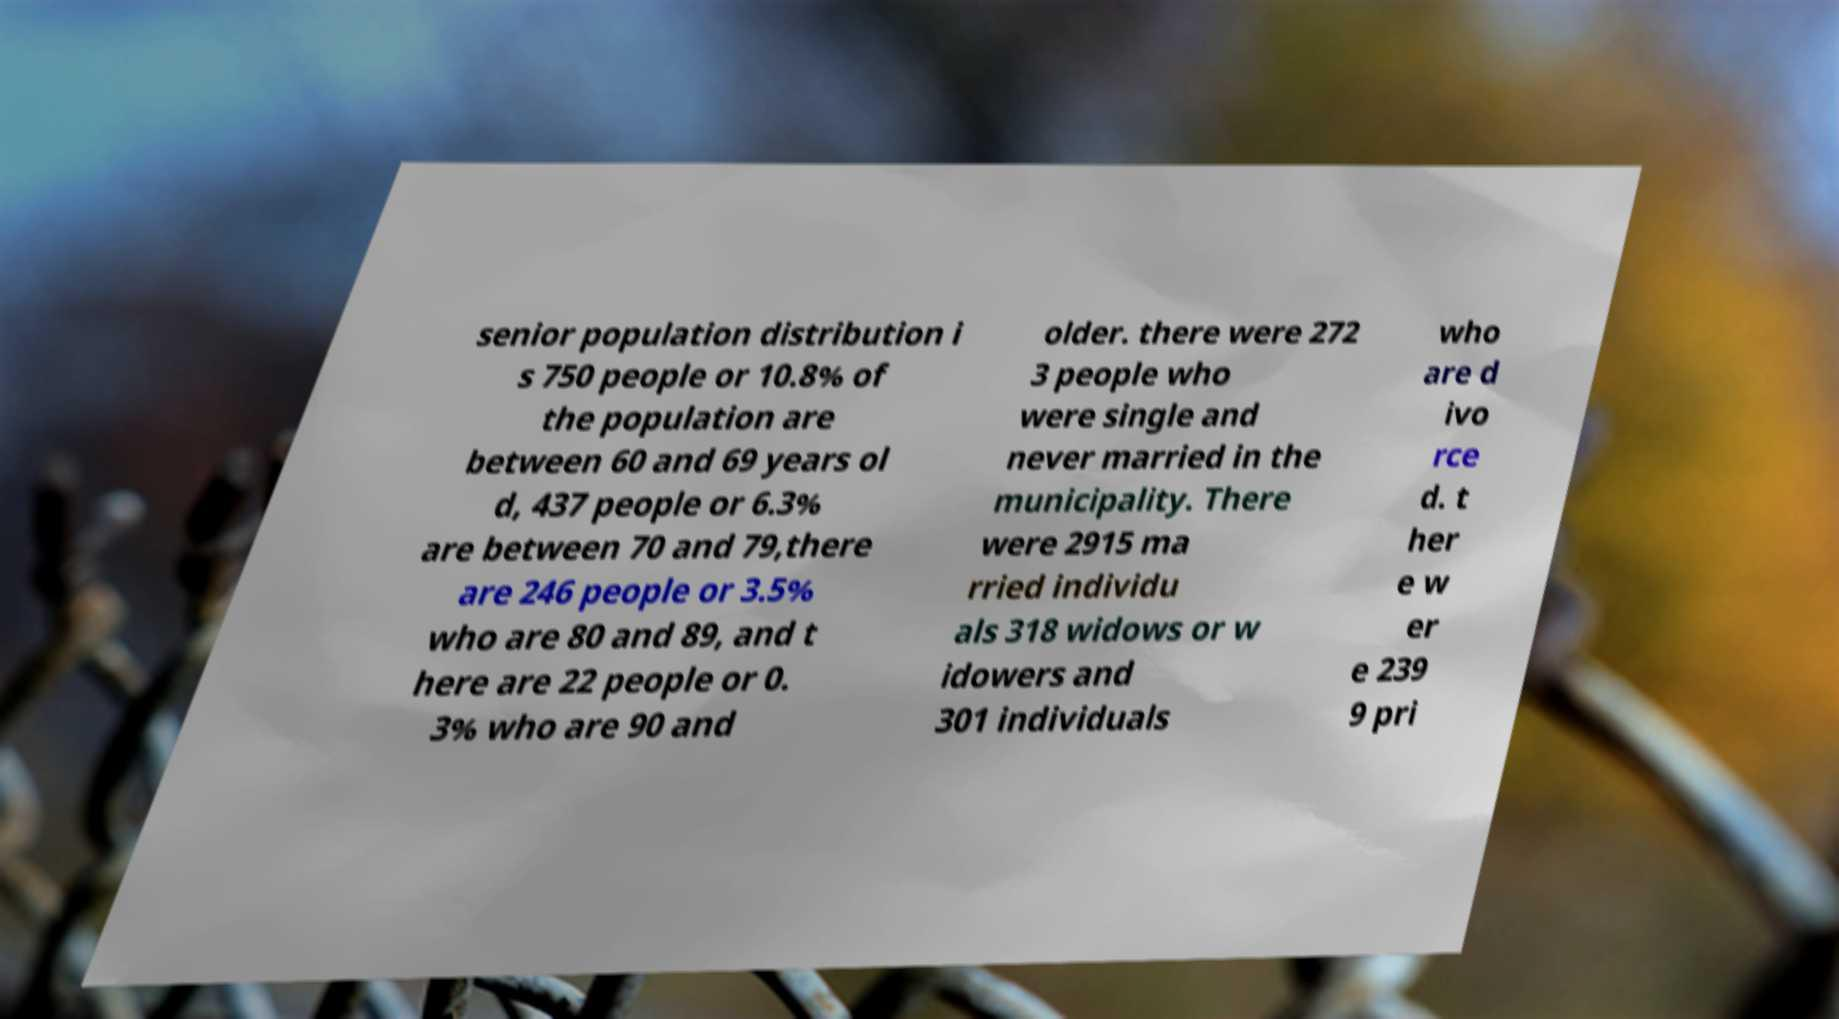Can you accurately transcribe the text from the provided image for me? senior population distribution i s 750 people or 10.8% of the population are between 60 and 69 years ol d, 437 people or 6.3% are between 70 and 79,there are 246 people or 3.5% who are 80 and 89, and t here are 22 people or 0. 3% who are 90 and older. there were 272 3 people who were single and never married in the municipality. There were 2915 ma rried individu als 318 widows or w idowers and 301 individuals who are d ivo rce d. t her e w er e 239 9 pri 